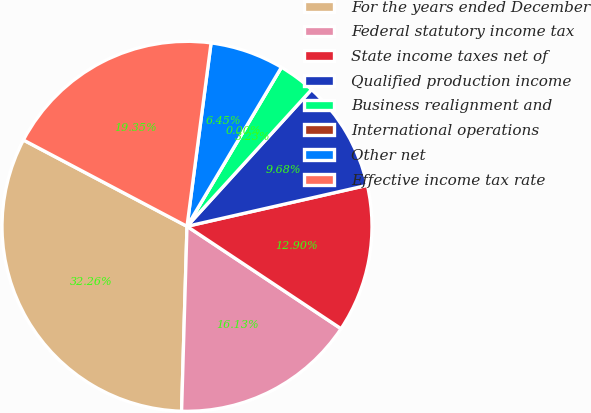<chart> <loc_0><loc_0><loc_500><loc_500><pie_chart><fcel>For the years ended December<fcel>Federal statutory income tax<fcel>State income taxes net of<fcel>Qualified production income<fcel>Business realignment and<fcel>International operations<fcel>Other net<fcel>Effective income tax rate<nl><fcel>32.26%<fcel>16.13%<fcel>12.9%<fcel>9.68%<fcel>3.23%<fcel>0.0%<fcel>6.45%<fcel>19.35%<nl></chart> 